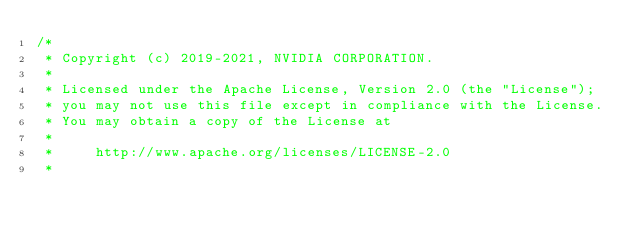<code> <loc_0><loc_0><loc_500><loc_500><_Cuda_>/*
 * Copyright (c) 2019-2021, NVIDIA CORPORATION.
 *
 * Licensed under the Apache License, Version 2.0 (the "License");
 * you may not use this file except in compliance with the License.
 * You may obtain a copy of the License at
 *
 *     http://www.apache.org/licenses/LICENSE-2.0
 *</code> 